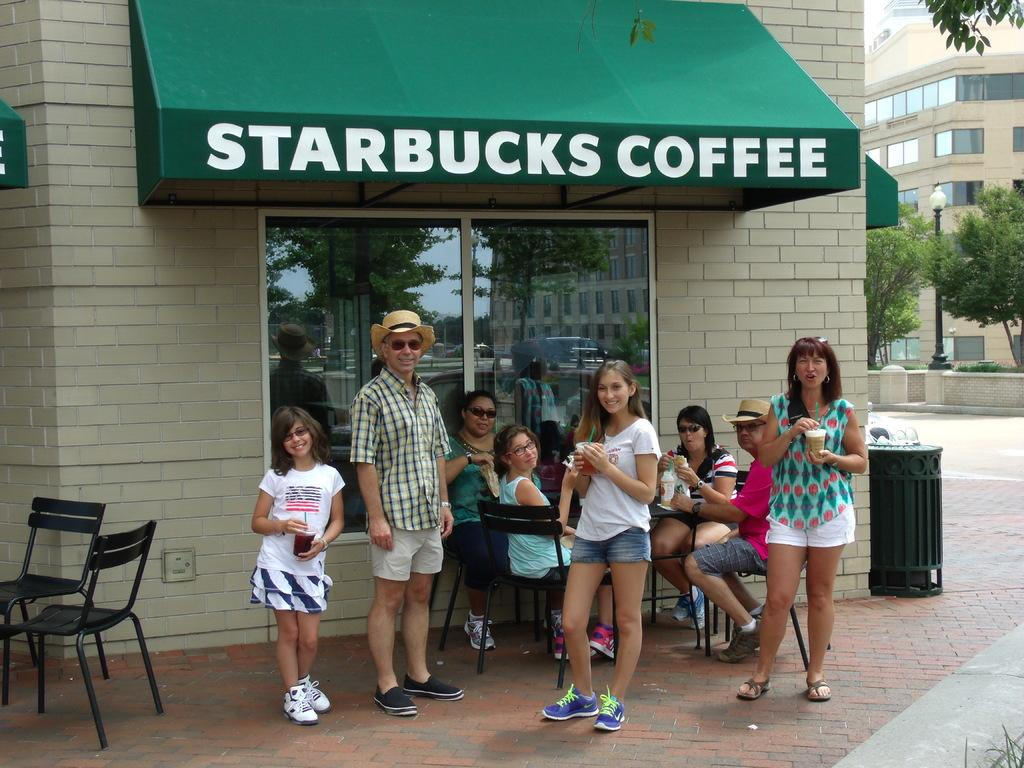What type of structure can be seen in the image? There is a building in the image. What else is present in the image besides the building? There is a wall, trees, a road, people standing, people sitting on chairs, and a table in the image. Can you describe the people in the image? There are people standing and people sitting on chairs in the image. What is the purpose of the table in the image? The presence of chairs and people sitting suggests that the table might be used for dining or other activities. What type of can is visible on the table in the image? There is no can present on the table in the image. What color is the honey dripping from the sweater in the image? There is no honey or sweater present in the image. 